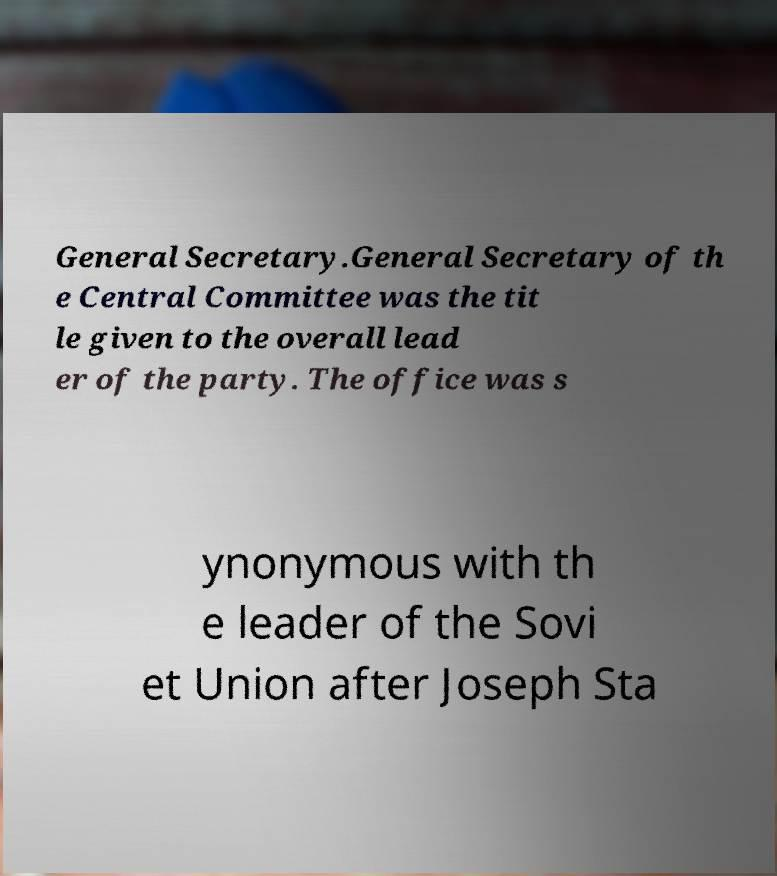Could you assist in decoding the text presented in this image and type it out clearly? General Secretary.General Secretary of th e Central Committee was the tit le given to the overall lead er of the party. The office was s ynonymous with th e leader of the Sovi et Union after Joseph Sta 